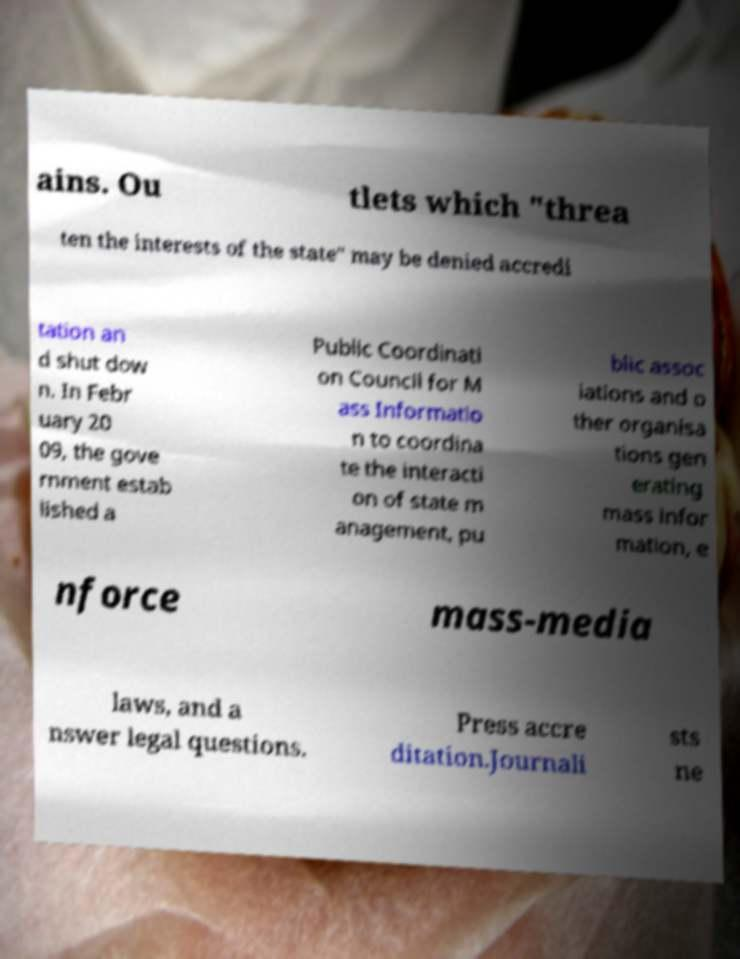What messages or text are displayed in this image? I need them in a readable, typed format. ains. Ou tlets which "threa ten the interests of the state" may be denied accredi tation an d shut dow n. In Febr uary 20 09, the gove rnment estab lished a Public Coordinati on Council for M ass Informatio n to coordina te the interacti on of state m anagement, pu blic assoc iations and o ther organisa tions gen erating mass infor mation, e nforce mass-media laws, and a nswer legal questions. Press accre ditation.Journali sts ne 